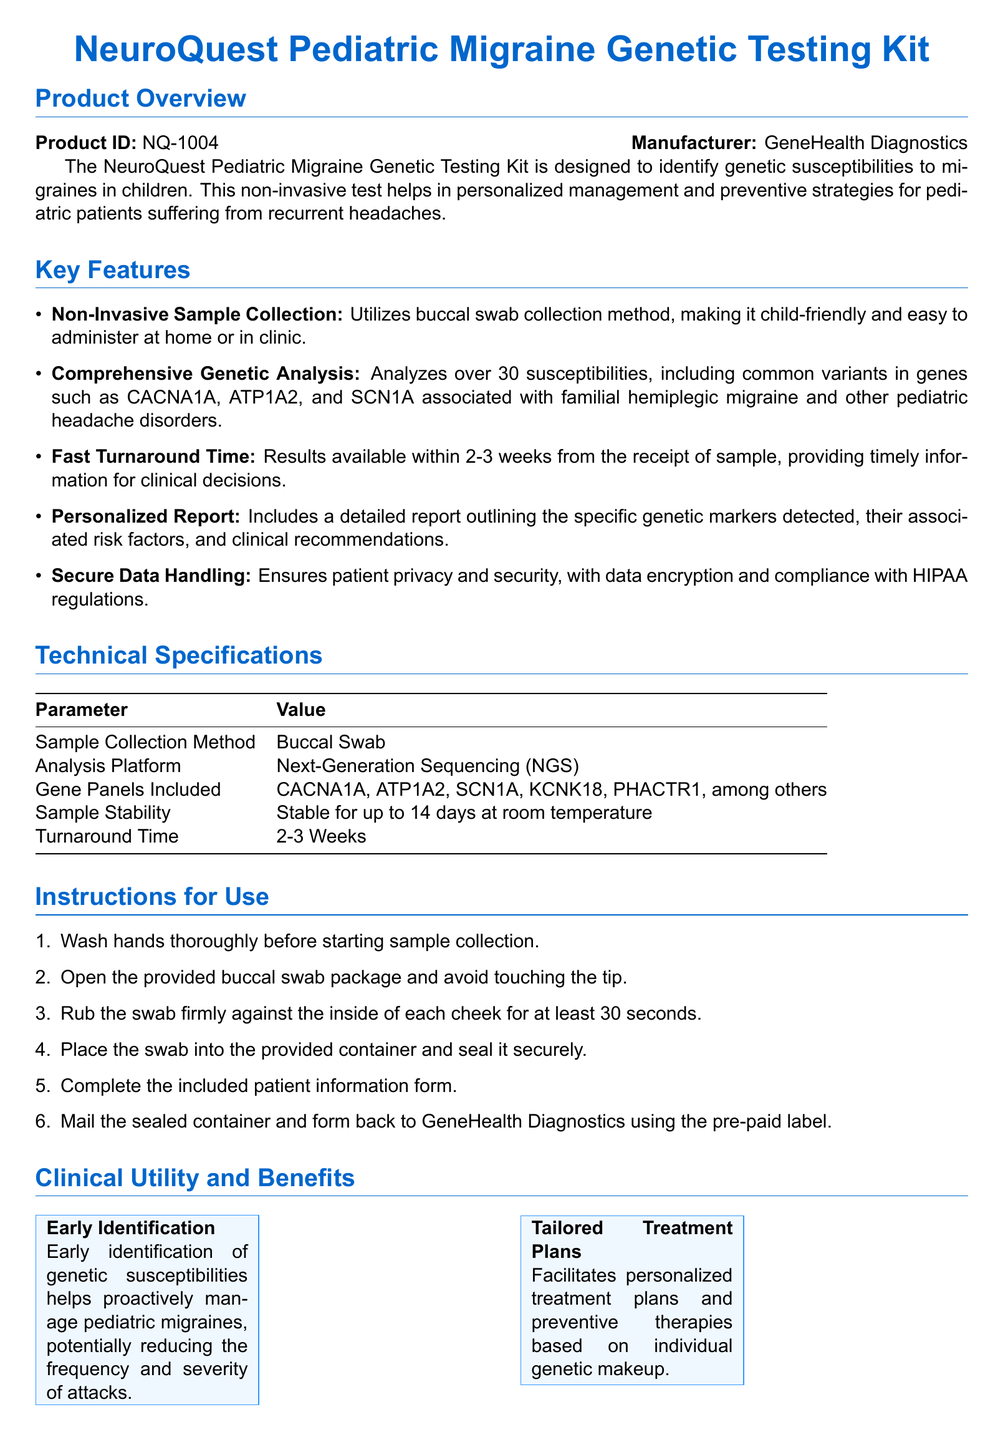what is the product ID? The product ID is a specific identifier for the testing kit mentioned in the document.
Answer: NQ-1004 who is the manufacturer? The manufacturer is the company responsible for producing the testing kit.
Answer: GeneHealth Diagnostics what is the sample collection method? The method used for collecting samples is described in the document under key features.
Answer: Buccal Swab how many genetic susceptibilities does the test analyze? This information is provided in the key features section, indicating the extent of the genetic analysis.
Answer: Over 30 what is the turnaround time for results? The document specifies the time frame from sample receipt to results availability.
Answer: 2-3 Weeks which genes are included in the analysis? The genes mentioned in the technical specifications represent part of the analysis framework.
Answer: CACNA1A, ATP1A2, SCN1A, KCNK18, PHACTR1 what certifications does the product have? The compliance section lists the accreditations and certifications obtained for the testing process.
Answer: CLIA Certified, CAP Accredited, HIPAA Compliant how does the kit facilitate personalized treatment plans? This question requires understanding the benefits provided by the kit as outlined in the document.
Answer: Based on individual genetic makeup what is the primary purpose of the NeuroQuest Pediatric Migraine Genetic Testing Kit? The overview section outlines the main purpose of the product and its target user.
Answer: Identify genetic susceptibilities to migraines in children 